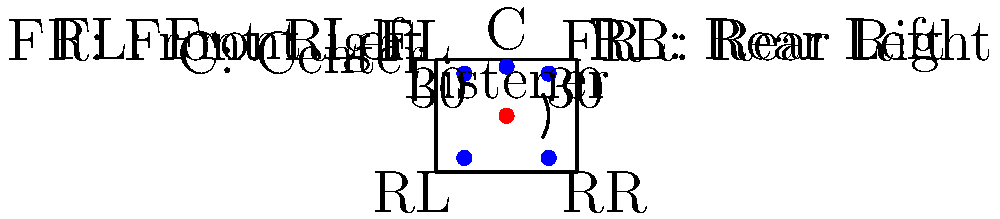In a 5.1 surround sound setup, what is the optimal angle between the front left and front right speakers relative to the listener's position? To determine the optimal angle between the front left and front right speakers in a 5.1 surround sound setup, we need to consider the following steps:

1. Understand the standard 5.1 surround sound configuration:
   - Center channel (C) directly in front of the listener
   - Front Left (FL) and Front Right (FR) speakers to the left and right of the center channel
   - Rear Left (RL) and Rear Right (RR) speakers behind the listener
   - Subwoofer (the ".1" in 5.1) for low-frequency effects

2. Recognize industry standards:
   - ITU (International Telecommunication Union) and THX recommendations are widely accepted

3. Identify the optimal angle:
   - The ITU-R BS.775-1 standard recommends a 60-degree total angle between FL and FR
   - This means a 30-degree angle from the center line to each front speaker

4. Understand the reasoning:
   - This angle provides the best stereo imaging and sound stage
   - It allows for proper localization of sound sources
   - It maintains a balanced soundfield across the front of the listening area

5. Apply the knowledge:
   - In the diagram, we can see that the FL and FR speakers are positioned at a 30-degree angle from the center line on each side
   - This creates a total 60-degree angle between FL and FR relative to the listener's position

6. Consider room acoustics:
   - While 60 degrees is optimal, slight adjustments may be necessary depending on room characteristics and speaker performance

By following these guidelines, we ensure that the front left and front right speakers are positioned to create the most accurate and immersive soundstage for the listener in a 5.1 surround sound setup.
Answer: 60 degrees 